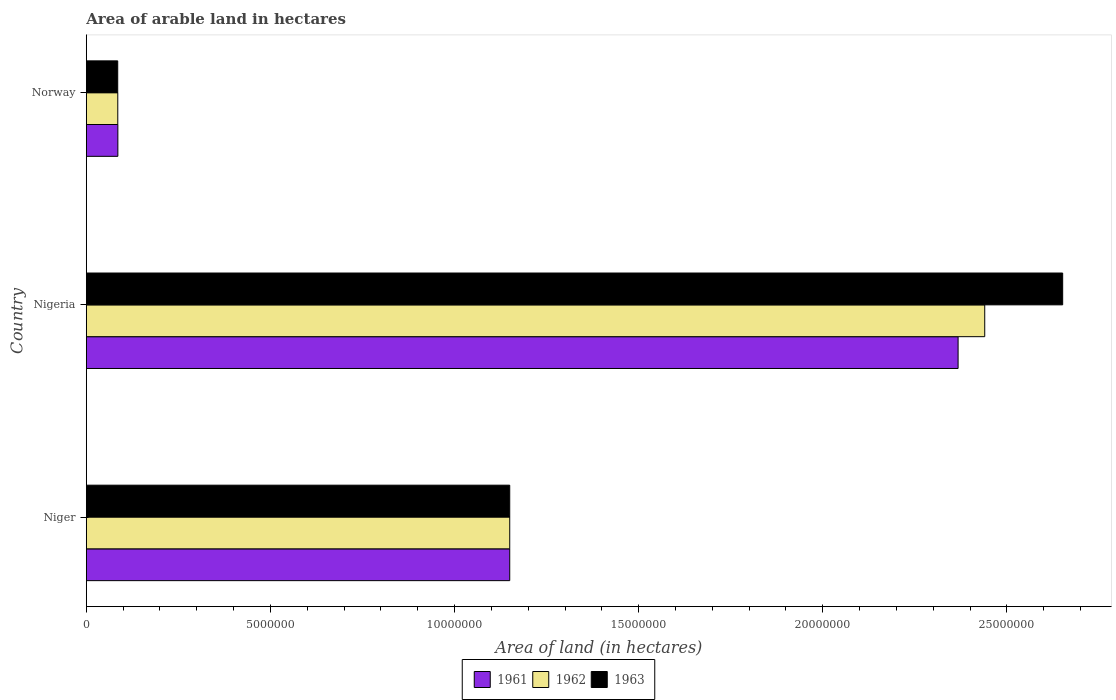How many different coloured bars are there?
Your answer should be compact. 3. How many bars are there on the 1st tick from the top?
Keep it short and to the point. 3. What is the label of the 3rd group of bars from the top?
Your answer should be compact. Niger. What is the total arable land in 1962 in Niger?
Keep it short and to the point. 1.15e+07. Across all countries, what is the maximum total arable land in 1961?
Offer a very short reply. 2.37e+07. Across all countries, what is the minimum total arable land in 1963?
Make the answer very short. 8.52e+05. In which country was the total arable land in 1961 maximum?
Ensure brevity in your answer.  Nigeria. What is the total total arable land in 1963 in the graph?
Provide a short and direct response. 3.89e+07. What is the difference between the total arable land in 1961 in Niger and that in Norway?
Ensure brevity in your answer.  1.06e+07. What is the difference between the total arable land in 1961 in Niger and the total arable land in 1963 in Nigeria?
Provide a succinct answer. -1.50e+07. What is the average total arable land in 1962 per country?
Give a very brief answer. 1.23e+07. What is the difference between the total arable land in 1961 and total arable land in 1963 in Nigeria?
Your answer should be compact. -2.84e+06. In how many countries, is the total arable land in 1963 greater than 12000000 hectares?
Make the answer very short. 1. What is the ratio of the total arable land in 1963 in Niger to that in Nigeria?
Your response must be concise. 0.43. Is the difference between the total arable land in 1961 in Nigeria and Norway greater than the difference between the total arable land in 1963 in Nigeria and Norway?
Keep it short and to the point. No. What is the difference between the highest and the second highest total arable land in 1963?
Make the answer very short. 1.50e+07. What is the difference between the highest and the lowest total arable land in 1963?
Make the answer very short. 2.57e+07. In how many countries, is the total arable land in 1961 greater than the average total arable land in 1961 taken over all countries?
Keep it short and to the point. 1. What does the 2nd bar from the top in Norway represents?
Provide a succinct answer. 1962. What does the 3rd bar from the bottom in Nigeria represents?
Ensure brevity in your answer.  1963. Is it the case that in every country, the sum of the total arable land in 1963 and total arable land in 1961 is greater than the total arable land in 1962?
Make the answer very short. Yes. How many bars are there?
Keep it short and to the point. 9. What is the difference between two consecutive major ticks on the X-axis?
Offer a very short reply. 5.00e+06. What is the title of the graph?
Provide a short and direct response. Area of arable land in hectares. What is the label or title of the X-axis?
Give a very brief answer. Area of land (in hectares). What is the Area of land (in hectares) in 1961 in Niger?
Offer a very short reply. 1.15e+07. What is the Area of land (in hectares) in 1962 in Niger?
Offer a very short reply. 1.15e+07. What is the Area of land (in hectares) in 1963 in Niger?
Your answer should be compact. 1.15e+07. What is the Area of land (in hectares) of 1961 in Nigeria?
Your answer should be very brief. 2.37e+07. What is the Area of land (in hectares) in 1962 in Nigeria?
Ensure brevity in your answer.  2.44e+07. What is the Area of land (in hectares) of 1963 in Nigeria?
Provide a succinct answer. 2.65e+07. What is the Area of land (in hectares) of 1961 in Norway?
Your answer should be compact. 8.56e+05. What is the Area of land (in hectares) in 1962 in Norway?
Your response must be concise. 8.54e+05. What is the Area of land (in hectares) in 1963 in Norway?
Provide a succinct answer. 8.52e+05. Across all countries, what is the maximum Area of land (in hectares) of 1961?
Keep it short and to the point. 2.37e+07. Across all countries, what is the maximum Area of land (in hectares) in 1962?
Offer a terse response. 2.44e+07. Across all countries, what is the maximum Area of land (in hectares) in 1963?
Your answer should be compact. 2.65e+07. Across all countries, what is the minimum Area of land (in hectares) in 1961?
Your answer should be very brief. 8.56e+05. Across all countries, what is the minimum Area of land (in hectares) of 1962?
Your answer should be compact. 8.54e+05. Across all countries, what is the minimum Area of land (in hectares) in 1963?
Make the answer very short. 8.52e+05. What is the total Area of land (in hectares) of 1961 in the graph?
Offer a terse response. 3.60e+07. What is the total Area of land (in hectares) of 1962 in the graph?
Offer a very short reply. 3.68e+07. What is the total Area of land (in hectares) of 1963 in the graph?
Give a very brief answer. 3.89e+07. What is the difference between the Area of land (in hectares) of 1961 in Niger and that in Nigeria?
Your response must be concise. -1.22e+07. What is the difference between the Area of land (in hectares) of 1962 in Niger and that in Nigeria?
Give a very brief answer. -1.29e+07. What is the difference between the Area of land (in hectares) in 1963 in Niger and that in Nigeria?
Keep it short and to the point. -1.50e+07. What is the difference between the Area of land (in hectares) of 1961 in Niger and that in Norway?
Keep it short and to the point. 1.06e+07. What is the difference between the Area of land (in hectares) of 1962 in Niger and that in Norway?
Provide a short and direct response. 1.06e+07. What is the difference between the Area of land (in hectares) in 1963 in Niger and that in Norway?
Offer a terse response. 1.06e+07. What is the difference between the Area of land (in hectares) of 1961 in Nigeria and that in Norway?
Your answer should be very brief. 2.28e+07. What is the difference between the Area of land (in hectares) of 1962 in Nigeria and that in Norway?
Offer a very short reply. 2.35e+07. What is the difference between the Area of land (in hectares) in 1963 in Nigeria and that in Norway?
Make the answer very short. 2.57e+07. What is the difference between the Area of land (in hectares) of 1961 in Niger and the Area of land (in hectares) of 1962 in Nigeria?
Provide a succinct answer. -1.29e+07. What is the difference between the Area of land (in hectares) in 1961 in Niger and the Area of land (in hectares) in 1963 in Nigeria?
Offer a terse response. -1.50e+07. What is the difference between the Area of land (in hectares) in 1962 in Niger and the Area of land (in hectares) in 1963 in Nigeria?
Your response must be concise. -1.50e+07. What is the difference between the Area of land (in hectares) in 1961 in Niger and the Area of land (in hectares) in 1962 in Norway?
Offer a very short reply. 1.06e+07. What is the difference between the Area of land (in hectares) in 1961 in Niger and the Area of land (in hectares) in 1963 in Norway?
Offer a terse response. 1.06e+07. What is the difference between the Area of land (in hectares) of 1962 in Niger and the Area of land (in hectares) of 1963 in Norway?
Make the answer very short. 1.06e+07. What is the difference between the Area of land (in hectares) of 1961 in Nigeria and the Area of land (in hectares) of 1962 in Norway?
Ensure brevity in your answer.  2.28e+07. What is the difference between the Area of land (in hectares) in 1961 in Nigeria and the Area of land (in hectares) in 1963 in Norway?
Ensure brevity in your answer.  2.28e+07. What is the difference between the Area of land (in hectares) in 1962 in Nigeria and the Area of land (in hectares) in 1963 in Norway?
Your answer should be compact. 2.35e+07. What is the average Area of land (in hectares) of 1961 per country?
Provide a short and direct response. 1.20e+07. What is the average Area of land (in hectares) in 1962 per country?
Provide a short and direct response. 1.23e+07. What is the average Area of land (in hectares) in 1963 per country?
Give a very brief answer. 1.30e+07. What is the difference between the Area of land (in hectares) in 1961 and Area of land (in hectares) in 1962 in Niger?
Your response must be concise. 0. What is the difference between the Area of land (in hectares) in 1961 and Area of land (in hectares) in 1963 in Niger?
Give a very brief answer. 0. What is the difference between the Area of land (in hectares) in 1962 and Area of land (in hectares) in 1963 in Niger?
Your answer should be very brief. 0. What is the difference between the Area of land (in hectares) in 1961 and Area of land (in hectares) in 1962 in Nigeria?
Provide a short and direct response. -7.23e+05. What is the difference between the Area of land (in hectares) of 1961 and Area of land (in hectares) of 1963 in Nigeria?
Your answer should be very brief. -2.84e+06. What is the difference between the Area of land (in hectares) in 1962 and Area of land (in hectares) in 1963 in Nigeria?
Your response must be concise. -2.12e+06. What is the difference between the Area of land (in hectares) in 1961 and Area of land (in hectares) in 1962 in Norway?
Your answer should be very brief. 2000. What is the difference between the Area of land (in hectares) in 1961 and Area of land (in hectares) in 1963 in Norway?
Provide a short and direct response. 4000. What is the ratio of the Area of land (in hectares) in 1961 in Niger to that in Nigeria?
Ensure brevity in your answer.  0.49. What is the ratio of the Area of land (in hectares) of 1962 in Niger to that in Nigeria?
Keep it short and to the point. 0.47. What is the ratio of the Area of land (in hectares) of 1963 in Niger to that in Nigeria?
Your answer should be compact. 0.43. What is the ratio of the Area of land (in hectares) in 1961 in Niger to that in Norway?
Your response must be concise. 13.43. What is the ratio of the Area of land (in hectares) in 1962 in Niger to that in Norway?
Offer a terse response. 13.46. What is the ratio of the Area of land (in hectares) of 1963 in Niger to that in Norway?
Your answer should be compact. 13.5. What is the ratio of the Area of land (in hectares) of 1961 in Nigeria to that in Norway?
Make the answer very short. 27.66. What is the ratio of the Area of land (in hectares) of 1962 in Nigeria to that in Norway?
Offer a terse response. 28.57. What is the ratio of the Area of land (in hectares) of 1963 in Nigeria to that in Norway?
Your answer should be compact. 31.12. What is the difference between the highest and the second highest Area of land (in hectares) in 1961?
Your answer should be compact. 1.22e+07. What is the difference between the highest and the second highest Area of land (in hectares) in 1962?
Ensure brevity in your answer.  1.29e+07. What is the difference between the highest and the second highest Area of land (in hectares) of 1963?
Make the answer very short. 1.50e+07. What is the difference between the highest and the lowest Area of land (in hectares) in 1961?
Give a very brief answer. 2.28e+07. What is the difference between the highest and the lowest Area of land (in hectares) of 1962?
Ensure brevity in your answer.  2.35e+07. What is the difference between the highest and the lowest Area of land (in hectares) of 1963?
Provide a short and direct response. 2.57e+07. 